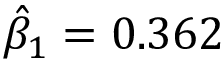<formula> <loc_0><loc_0><loc_500><loc_500>{ \hat { \beta } } _ { 1 } = 0 . 3 6 2</formula> 